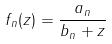<formula> <loc_0><loc_0><loc_500><loc_500>f _ { n } ( z ) = \frac { a _ { n } } { b _ { n } + z }</formula> 